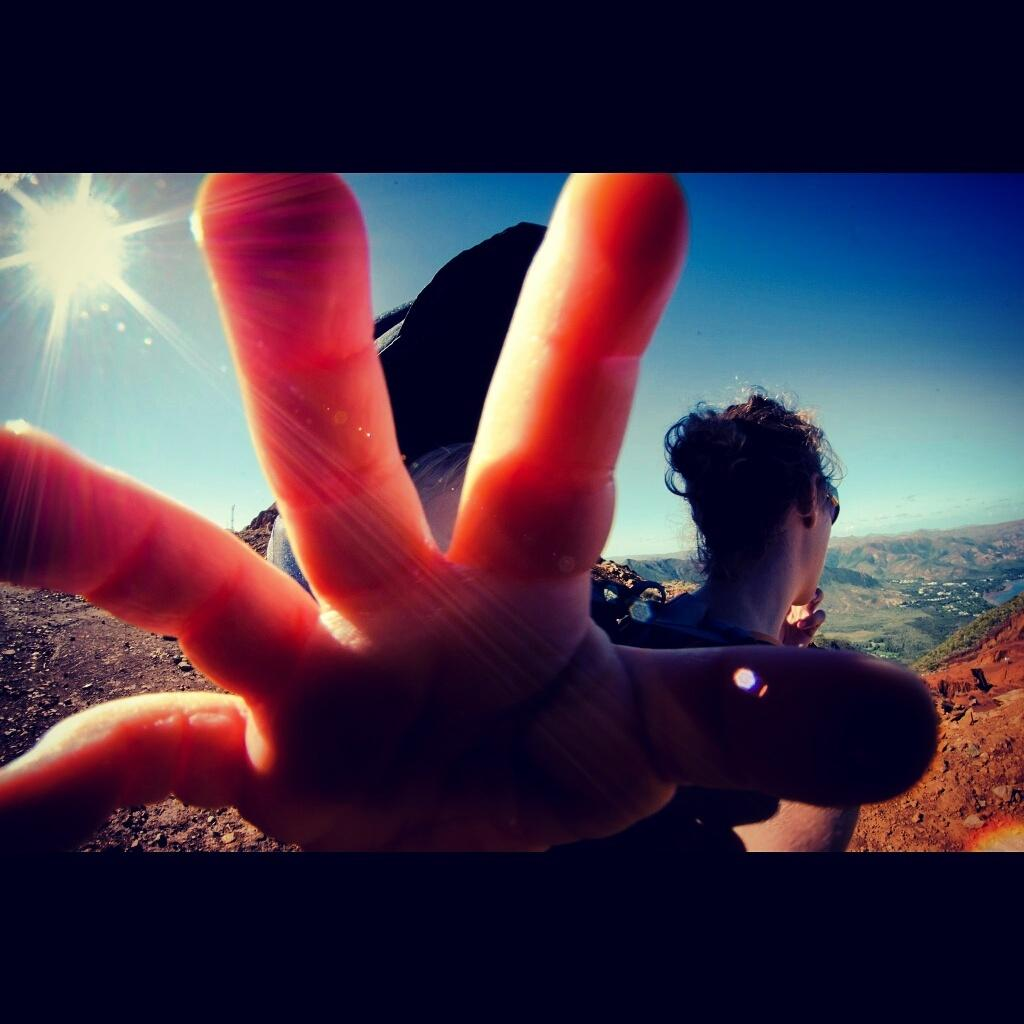What part of a person can be seen in the image? There is a lady's hand in the image. What type of landscape is visible in the background of the image? There are mountains in the background of the image. What is visible at the top of the image? The sky is visible at the top of the image, and it is clear. What type of sponge is being used by the lady in the image? There is no sponge visible in the image; only a lady's hand is present. What does the lady wish for in the image? There is no indication of a wish or any related activity in the image. 